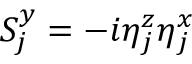Convert formula to latex. <formula><loc_0><loc_0><loc_500><loc_500>S _ { j } ^ { y } = - i \eta _ { j } ^ { z } \eta _ { j } ^ { x }</formula> 